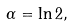Convert formula to latex. <formula><loc_0><loc_0><loc_500><loc_500>\alpha = \ln 2 ,</formula> 